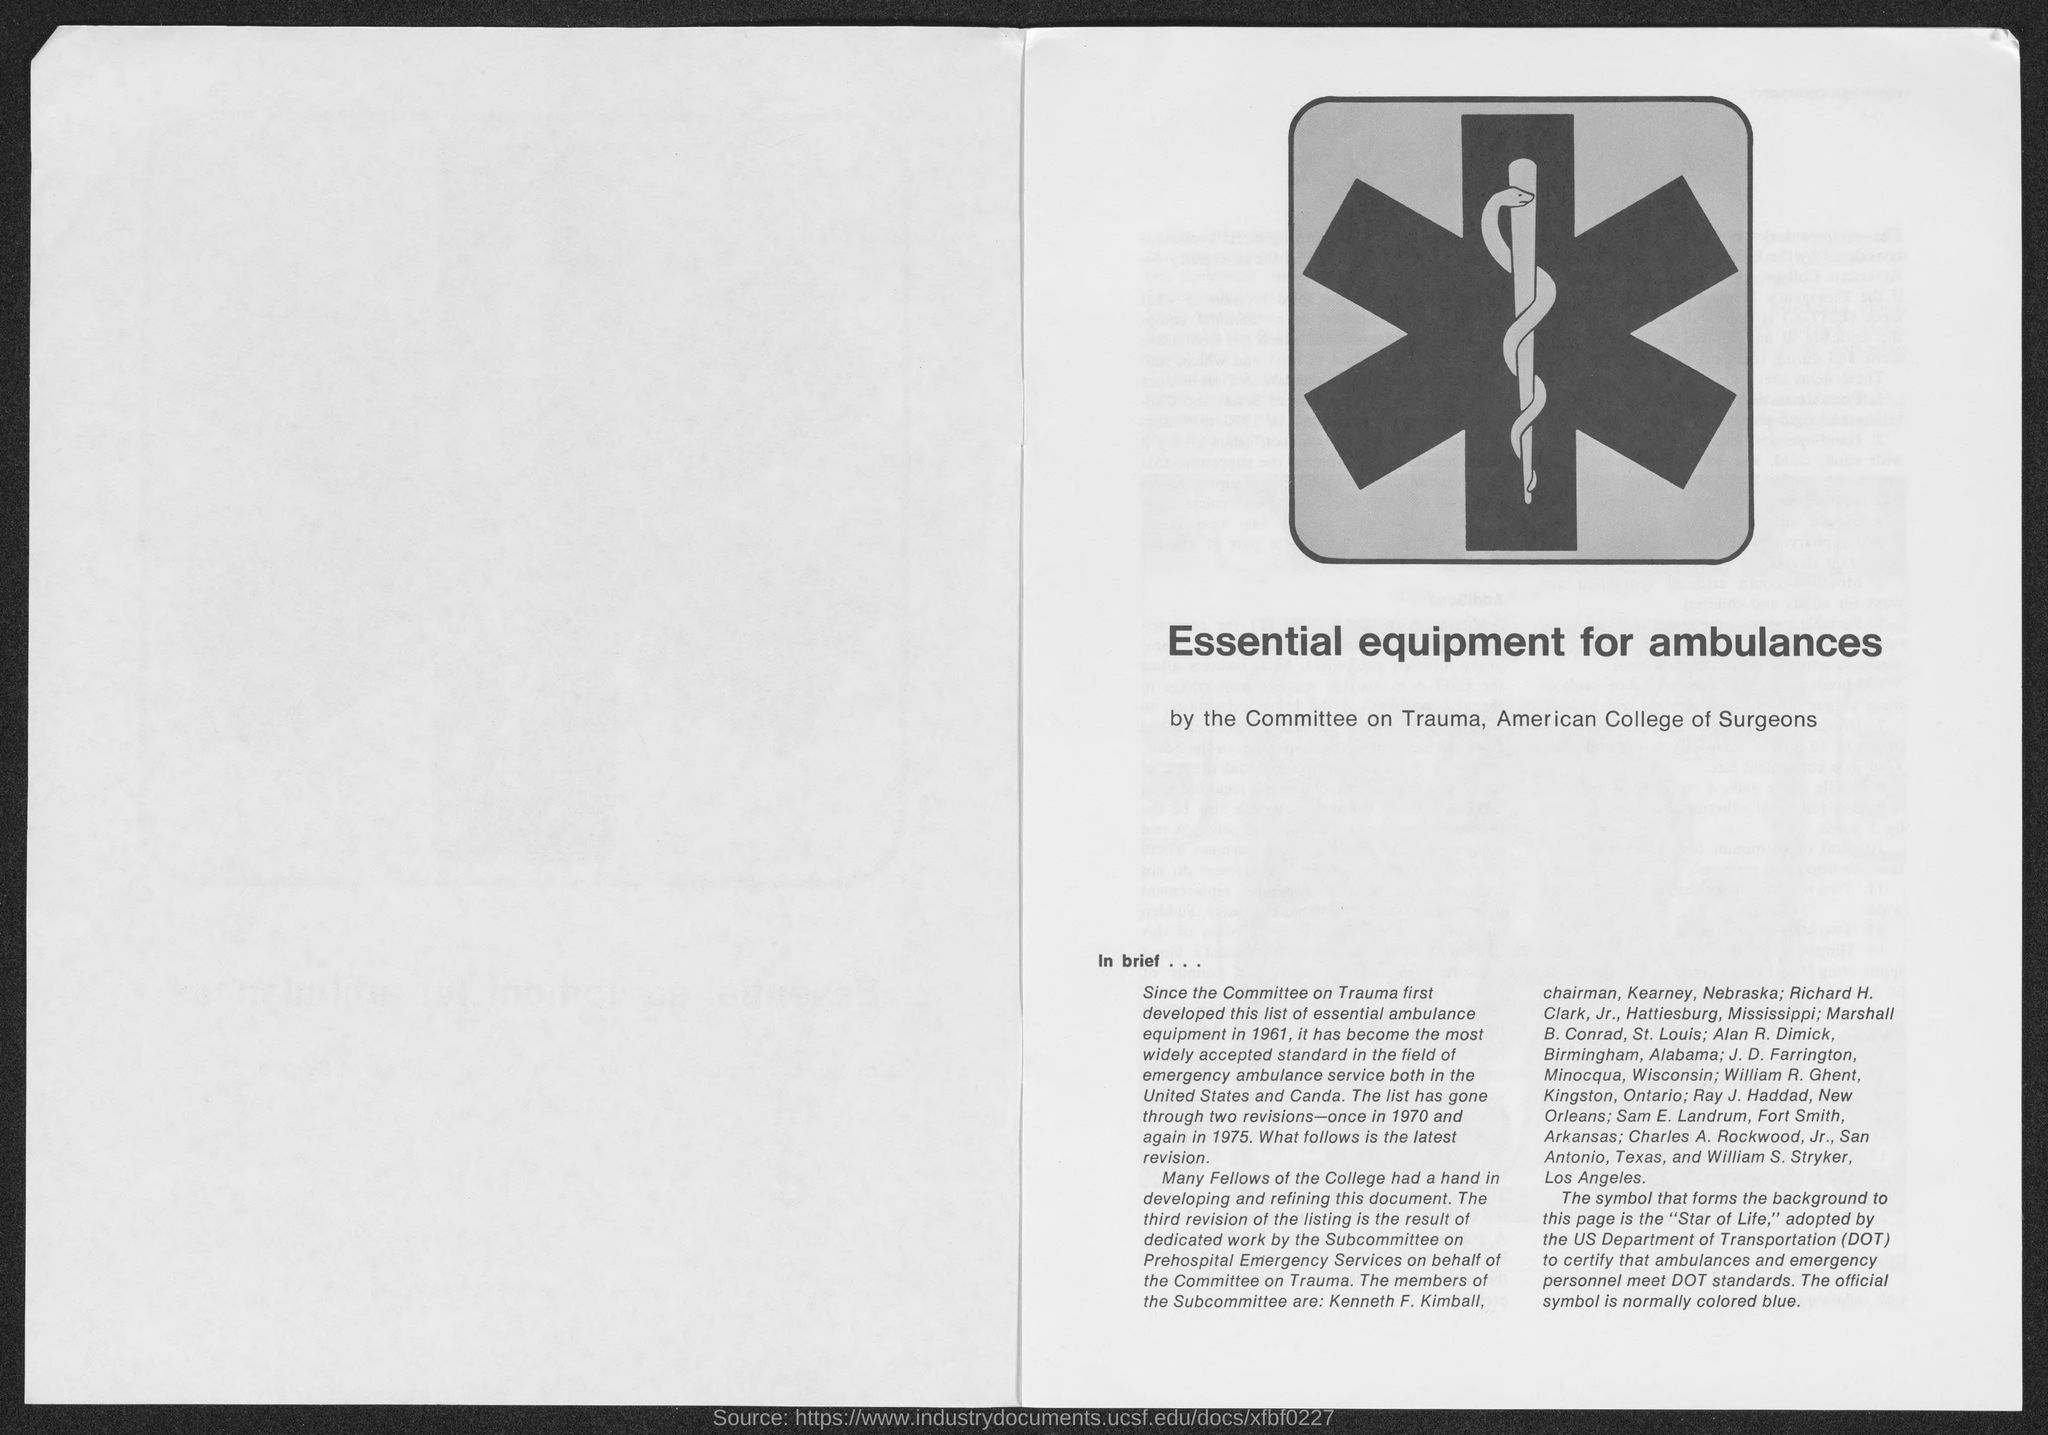What does dot stand for ?
Give a very brief answer. US Department of Transportation. 